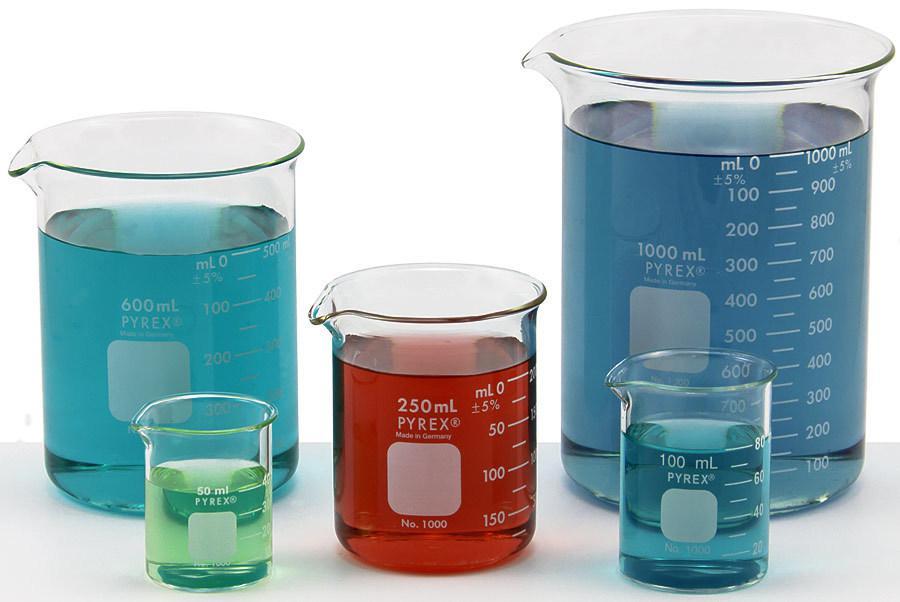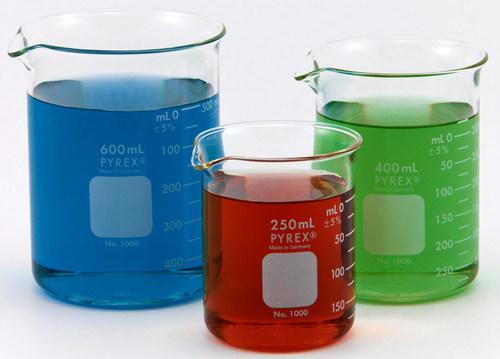The first image is the image on the left, the second image is the image on the right. For the images displayed, is the sentence "The left and right image contains a total of eight beakers." factually correct? Answer yes or no. Yes. The first image is the image on the left, the second image is the image on the right. Given the left and right images, does the statement "At least 7 beakers of varying sizes are filled with colorful liquid." hold true? Answer yes or no. Yes. 